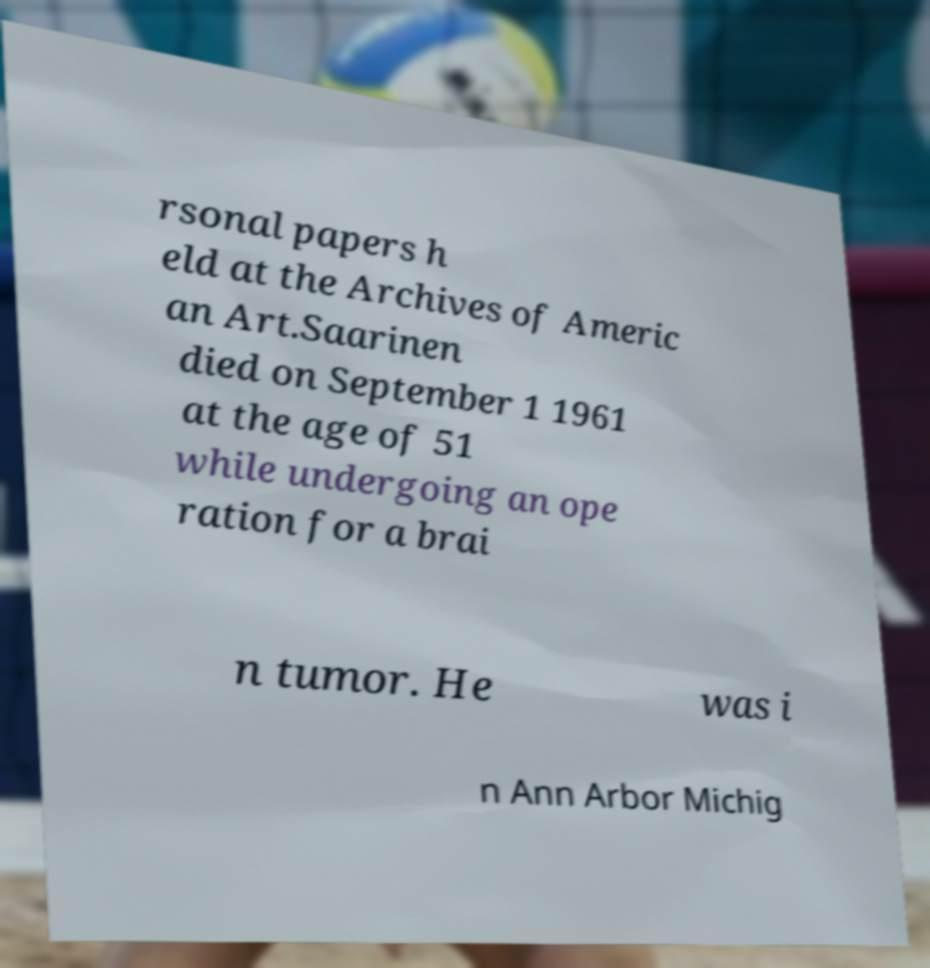I need the written content from this picture converted into text. Can you do that? rsonal papers h eld at the Archives of Americ an Art.Saarinen died on September 1 1961 at the age of 51 while undergoing an ope ration for a brai n tumor. He was i n Ann Arbor Michig 